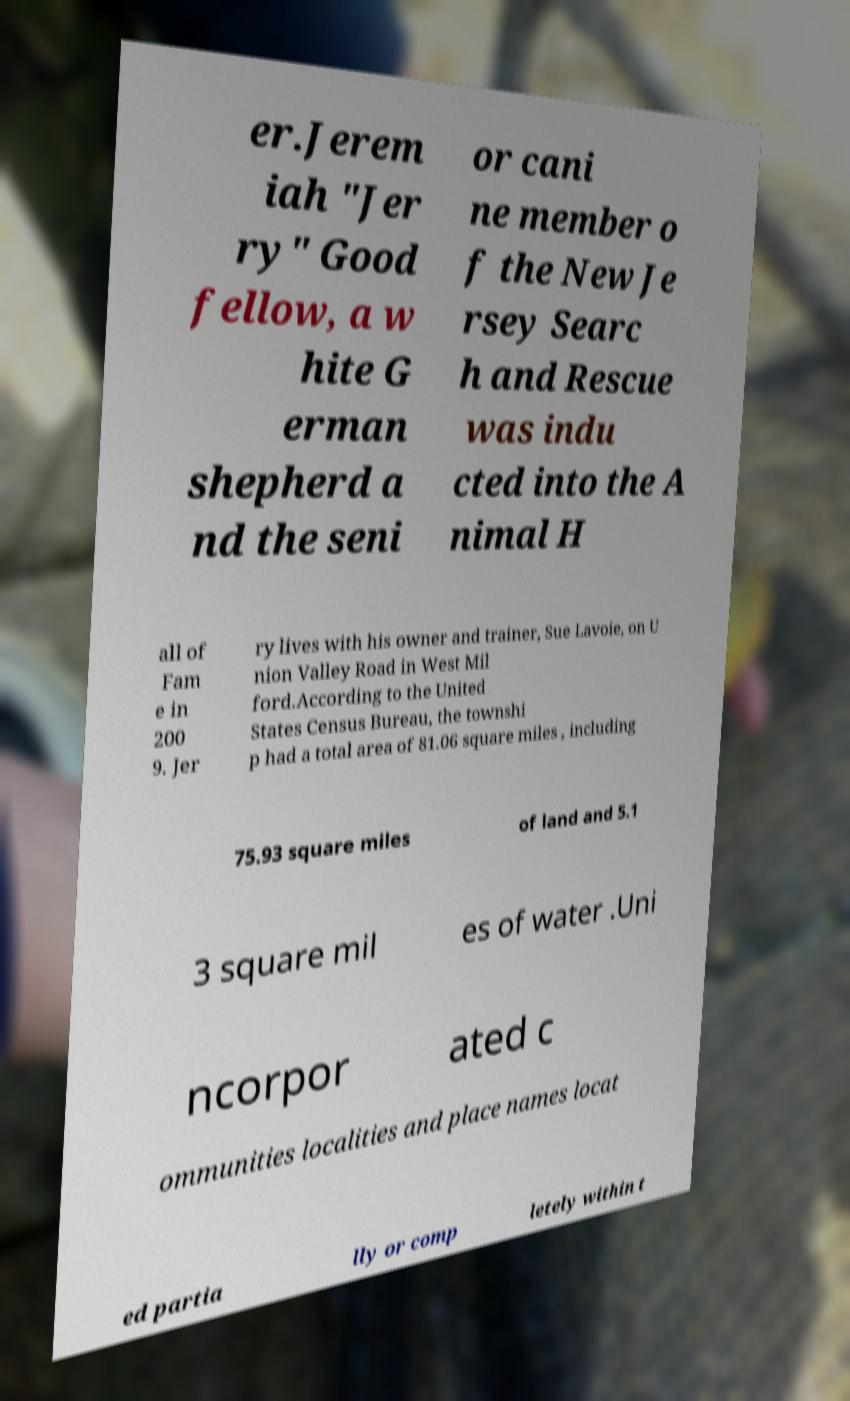What messages or text are displayed in this image? I need them in a readable, typed format. er.Jerem iah "Jer ry" Good fellow, a w hite G erman shepherd a nd the seni or cani ne member o f the New Je rsey Searc h and Rescue was indu cted into the A nimal H all of Fam e in 200 9. Jer ry lives with his owner and trainer, Sue Lavoie, on U nion Valley Road in West Mil ford.According to the United States Census Bureau, the townshi p had a total area of 81.06 square miles , including 75.93 square miles of land and 5.1 3 square mil es of water .Uni ncorpor ated c ommunities localities and place names locat ed partia lly or comp letely within t 